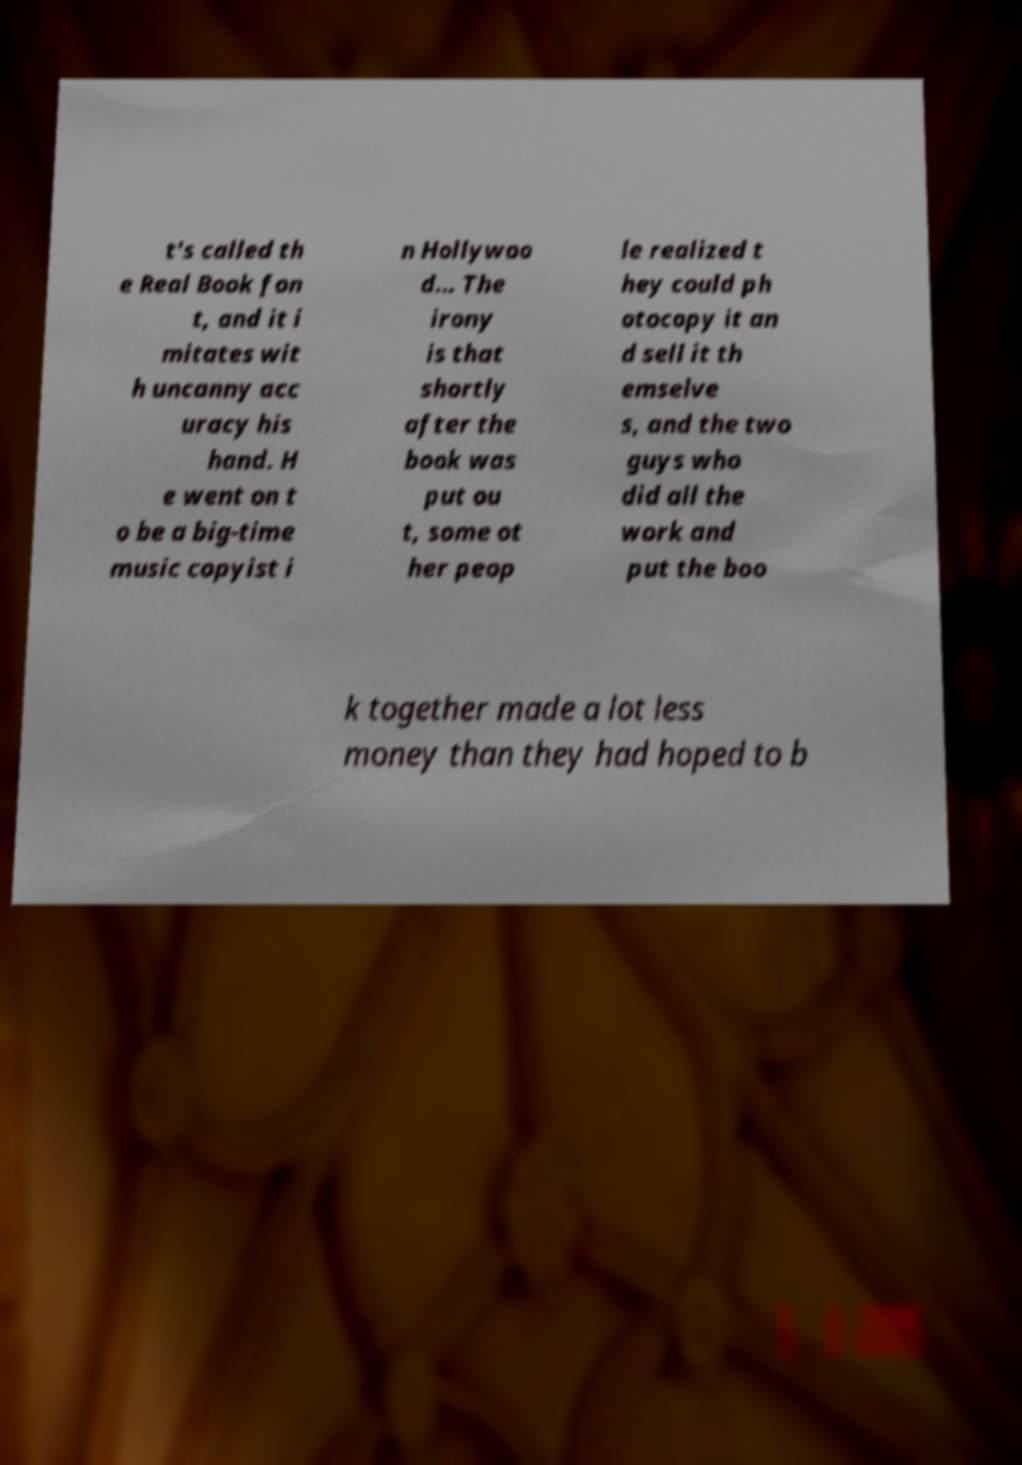I need the written content from this picture converted into text. Can you do that? t's called th e Real Book fon t, and it i mitates wit h uncanny acc uracy his hand. H e went on t o be a big-time music copyist i n Hollywoo d... The irony is that shortly after the book was put ou t, some ot her peop le realized t hey could ph otocopy it an d sell it th emselve s, and the two guys who did all the work and put the boo k together made a lot less money than they had hoped to b 